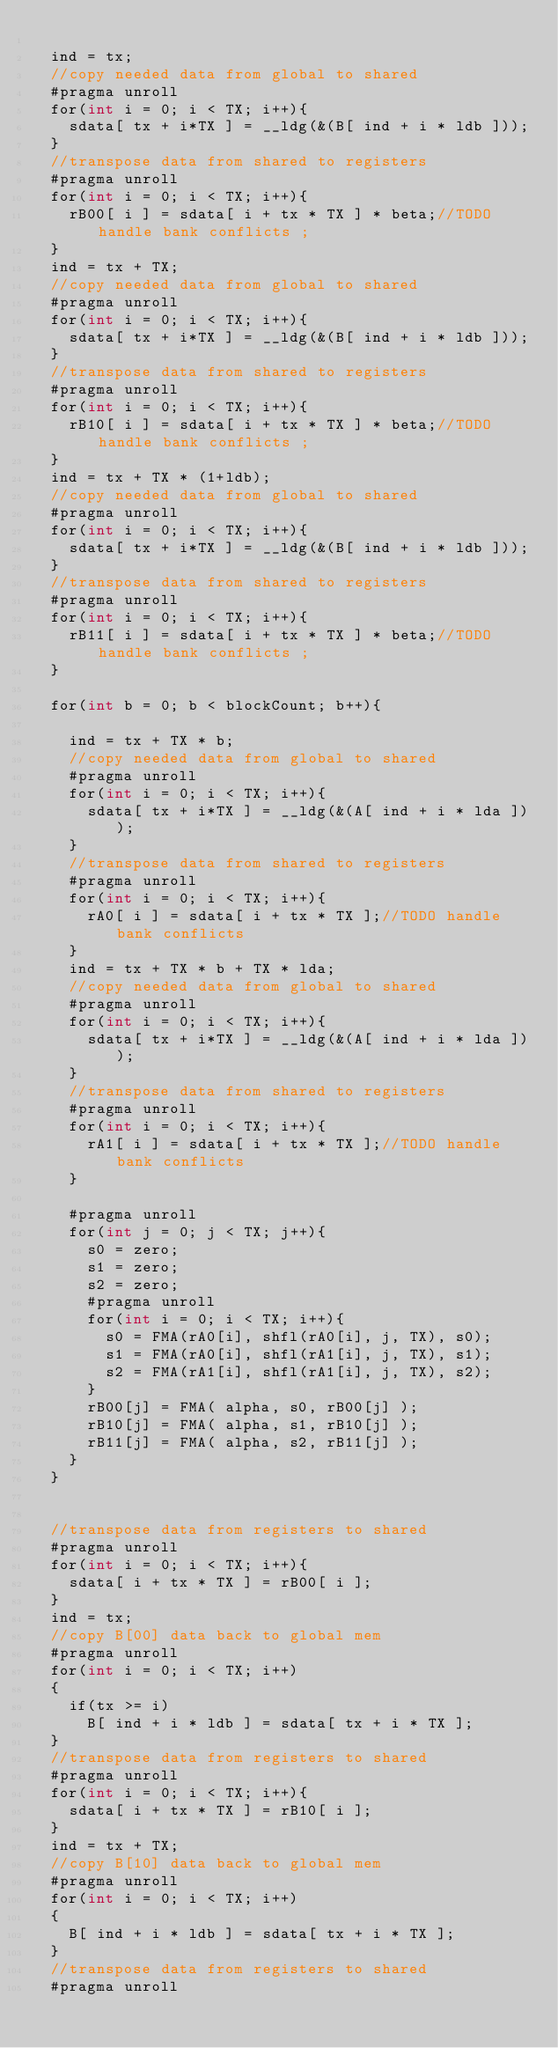Convert code to text. <code><loc_0><loc_0><loc_500><loc_500><_Cuda_>
  ind = tx;
  //copy needed data from global to shared
  #pragma unroll
  for(int i = 0; i < TX; i++){
    sdata[ tx + i*TX ] = __ldg(&(B[ ind + i * ldb ]));
  }
  //transpose data from shared to registers
  #pragma unroll
  for(int i = 0; i < TX; i++){
    rB00[ i ] = sdata[ i + tx * TX ] * beta;//TODO handle bank conflicts ;
  }
  ind = tx + TX;
  //copy needed data from global to shared
  #pragma unroll
  for(int i = 0; i < TX; i++){
    sdata[ tx + i*TX ] = __ldg(&(B[ ind + i * ldb ]));
  }
  //transpose data from shared to registers
  #pragma unroll
  for(int i = 0; i < TX; i++){
    rB10[ i ] = sdata[ i + tx * TX ] * beta;//TODO handle bank conflicts ;
  }
  ind = tx + TX * (1+ldb);
  //copy needed data from global to shared
  #pragma unroll
  for(int i = 0; i < TX; i++){
    sdata[ tx + i*TX ] = __ldg(&(B[ ind + i * ldb ]));
  }
  //transpose data from shared to registers
  #pragma unroll
  for(int i = 0; i < TX; i++){
    rB11[ i ] = sdata[ i + tx * TX ] * beta;//TODO handle bank conflicts ;
  }

  for(int b = 0; b < blockCount; b++){

    ind = tx + TX * b;
    //copy needed data from global to shared
    #pragma unroll
    for(int i = 0; i < TX; i++){
      sdata[ tx + i*TX ] = __ldg(&(A[ ind + i * lda ]));
    }
    //transpose data from shared to registers
    #pragma unroll
    for(int i = 0; i < TX; i++){
      rA0[ i ] = sdata[ i + tx * TX ];//TODO handle bank conflicts
    }
    ind = tx + TX * b + TX * lda;
    //copy needed data from global to shared
    #pragma unroll
    for(int i = 0; i < TX; i++){
      sdata[ tx + i*TX ] = __ldg(&(A[ ind + i * lda ]));
    }
    //transpose data from shared to registers
    #pragma unroll
    for(int i = 0; i < TX; i++){
      rA1[ i ] = sdata[ i + tx * TX ];//TODO handle bank conflicts
    }

    #pragma unroll
    for(int j = 0; j < TX; j++){
      s0 = zero;
      s1 = zero;
      s2 = zero;
      #pragma unroll
      for(int i = 0; i < TX; i++){
        s0 = FMA(rA0[i], shfl(rA0[i], j, TX), s0);
        s1 = FMA(rA0[i], shfl(rA1[i], j, TX), s1);
        s2 = FMA(rA1[i], shfl(rA1[i], j, TX), s2);
      }
      rB00[j] = FMA( alpha, s0, rB00[j] );
      rB10[j] = FMA( alpha, s1, rB10[j] );
      rB11[j] = FMA( alpha, s2, rB11[j] );
    }
  }


  //transpose data from registers to shared
  #pragma unroll
  for(int i = 0; i < TX; i++){
    sdata[ i + tx * TX ] = rB00[ i ];
  }
  ind = tx;
  //copy B[00] data back to global mem
  #pragma unroll
  for(int i = 0; i < TX; i++)
  {
    if(tx >= i)
      B[ ind + i * ldb ] = sdata[ tx + i * TX ];
  }
  //transpose data from registers to shared
  #pragma unroll
  for(int i = 0; i < TX; i++){
    sdata[ i + tx * TX ] = rB10[ i ];
  }
  ind = tx + TX;
  //copy B[10] data back to global mem
  #pragma unroll
  for(int i = 0; i < TX; i++)
  {
    B[ ind + i * ldb ] = sdata[ tx + i * TX ];
  }
  //transpose data from registers to shared
  #pragma unroll</code> 